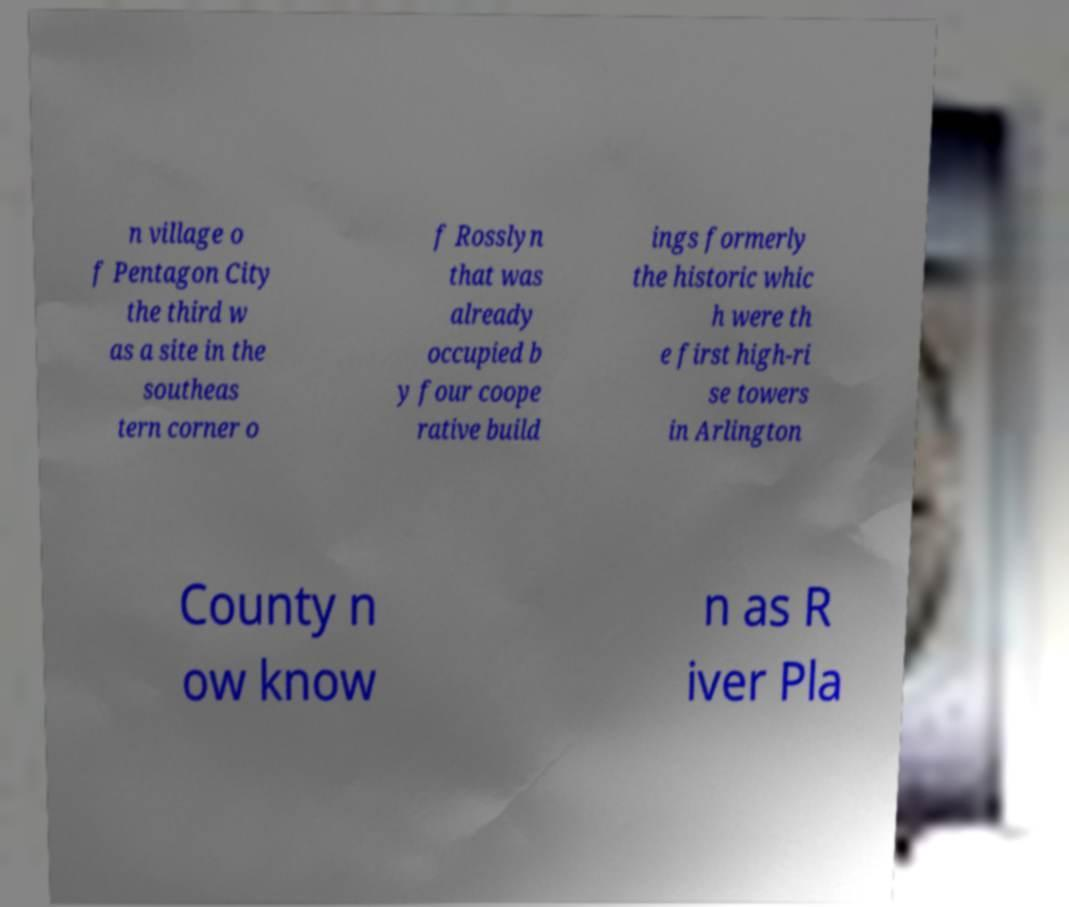Can you accurately transcribe the text from the provided image for me? n village o f Pentagon City the third w as a site in the southeas tern corner o f Rosslyn that was already occupied b y four coope rative build ings formerly the historic whic h were th e first high-ri se towers in Arlington County n ow know n as R iver Pla 